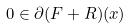Convert formula to latex. <formula><loc_0><loc_0><loc_500><loc_500>0 \in \partial ( F + R ) ( x )</formula> 